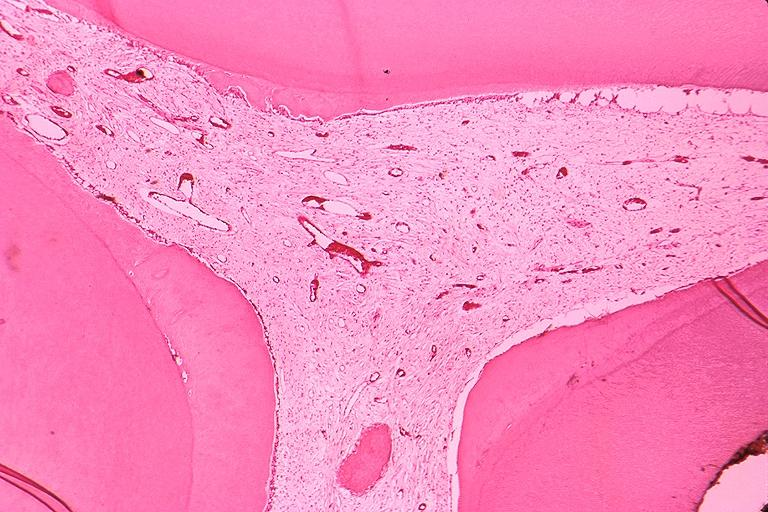does this image show secondary dentin and pulp calcification?
Answer the question using a single word or phrase. Yes 